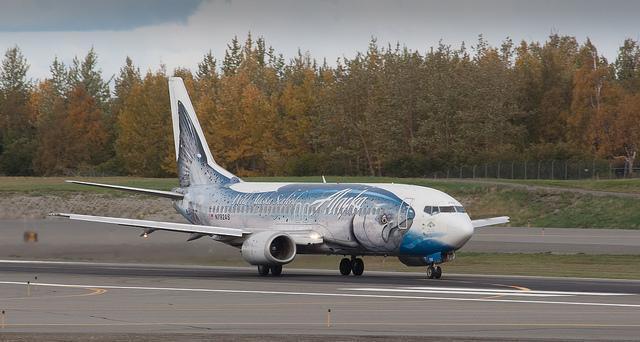How many standing cats are there?
Give a very brief answer. 0. 